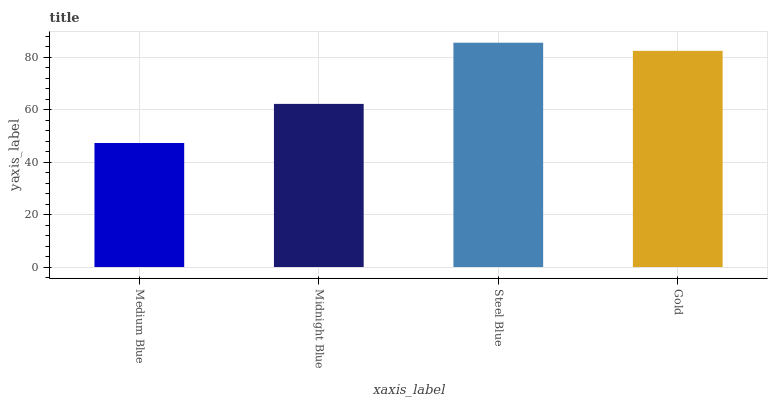Is Midnight Blue the minimum?
Answer yes or no. No. Is Midnight Blue the maximum?
Answer yes or no. No. Is Midnight Blue greater than Medium Blue?
Answer yes or no. Yes. Is Medium Blue less than Midnight Blue?
Answer yes or no. Yes. Is Medium Blue greater than Midnight Blue?
Answer yes or no. No. Is Midnight Blue less than Medium Blue?
Answer yes or no. No. Is Gold the high median?
Answer yes or no. Yes. Is Midnight Blue the low median?
Answer yes or no. Yes. Is Steel Blue the high median?
Answer yes or no. No. Is Gold the low median?
Answer yes or no. No. 